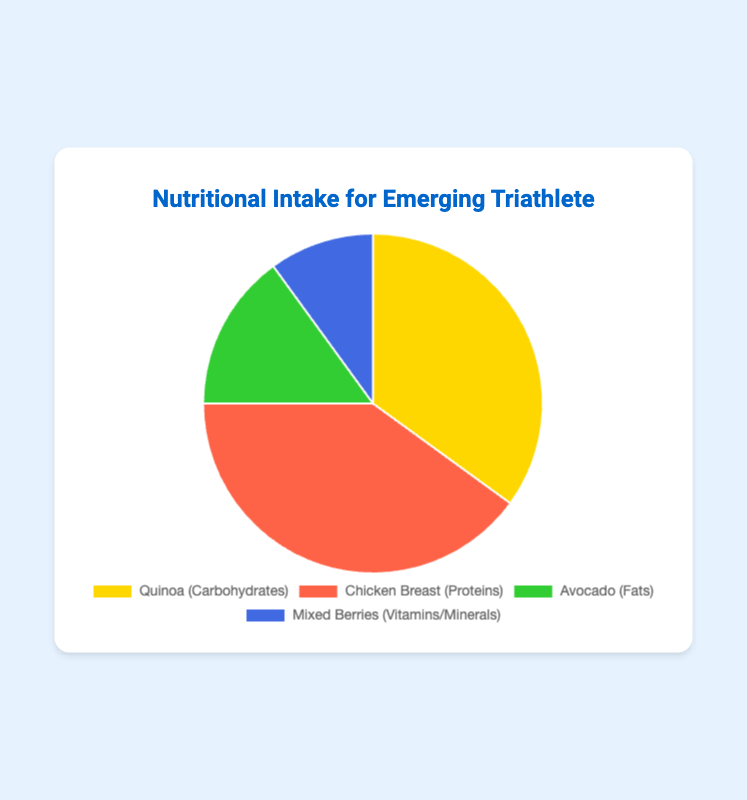What percentage of your nutritional intake comes from proteins? The pie chart shows that Chicken Breast represents the Proteins category. The percentage corresponding to Chicken Breast is 40%.
Answer: 40% Which nutritional source has the lowest percentage among the four? From the pie chart, we can see that Mixed Berries have the smallest portion, representing Vitamins/Minerals. The percentage is shown as 10%.
Answer: Mixed Berries How much more carbohydrates do you intake compared to fats? The chart shows that 35% of intake comes from Carbohydrates (Quinoa) and 15% from Fats (Avocado). The difference between these two percentages is 35% - 15% = 20%.
Answer: 20% What is the total percentage of your nutritional intake covered by non-macronutrient components (fats and vitamins/minerals)? The percentage for fats is 15% (Avocado) and for vitamins/minerals is 10% (Mixed Berries). The sum of these percentages is 15% + 10% = 25%.
Answer: 25% Which source contributes more to your nutritional intake, Quinoa or Avocado? Quinoa represents 35% (Carbohydrates) and Avocado represents 15% (Fats) of the intake. Since 35% is greater than 15%, Quinoa contributes more.
Answer: Quinoa What is the ratio of proteins to vitamins/minerals in your nutritional intake? Proteins (Chicken Breast) account for 40% of the intake and vitamins/minerals (Mixed Berries) for 10%. The ratio is 40:10, which simplifies to 4:1.
Answer: 4:1 Which source is represented by the green section of the pie chart? The pie chart's green section corresponds to Avocado, which represents the Fats category.
Answer: Avocado Which source's percentage share is closest to the combined share of fats and vitamins/minerals? Combined, fats (15%) and vitamins/minerals (10%) make up 25%. The closest individual category percentage to this combined share is Quinoa (Carbohydrates) with 35%.
Answer: Quinoa 